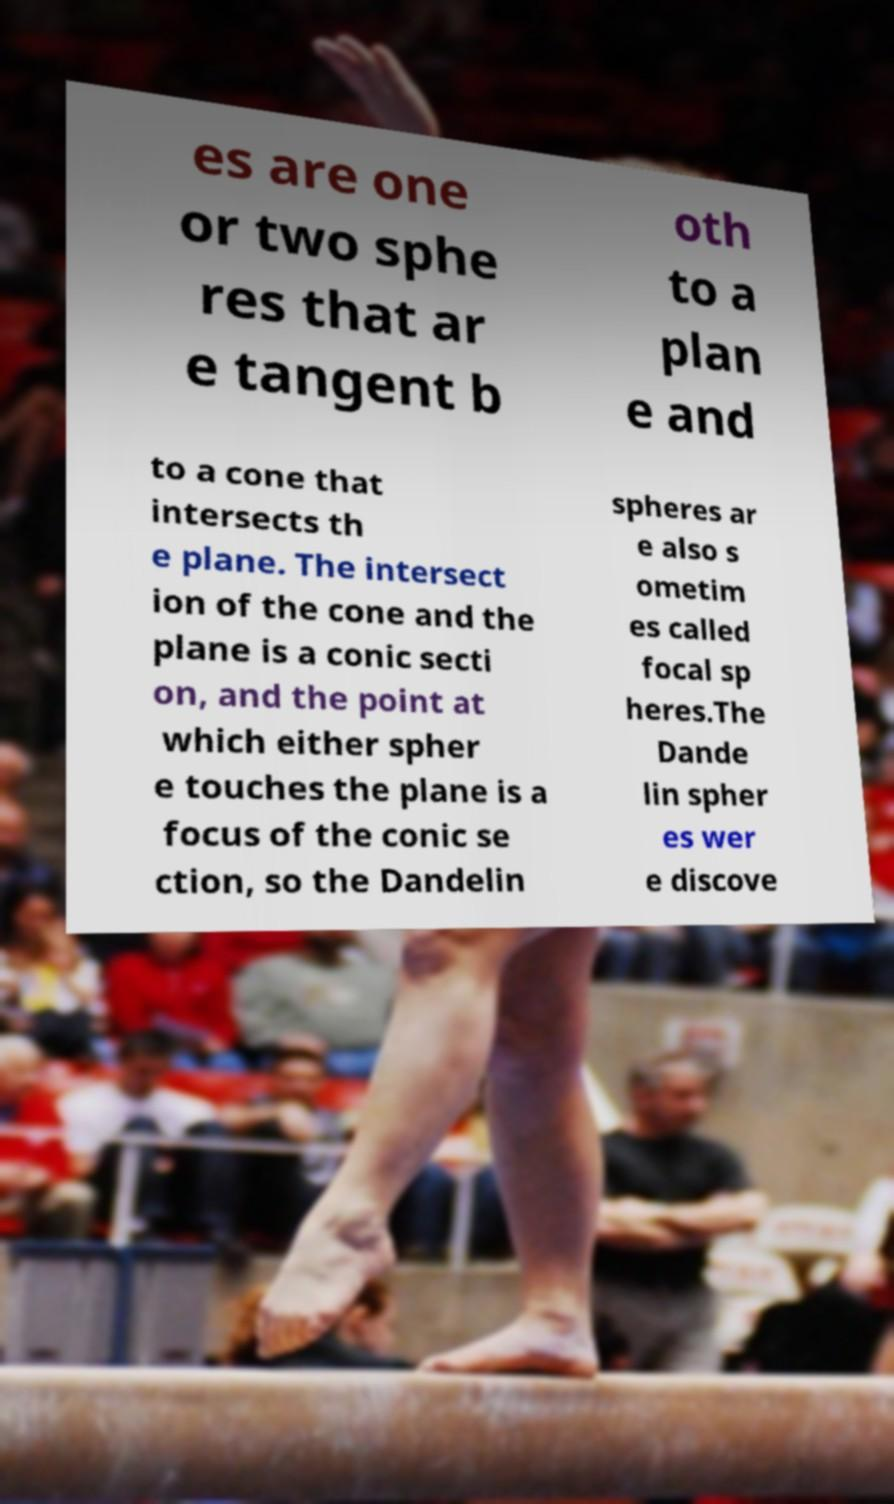There's text embedded in this image that I need extracted. Can you transcribe it verbatim? es are one or two sphe res that ar e tangent b oth to a plan e and to a cone that intersects th e plane. The intersect ion of the cone and the plane is a conic secti on, and the point at which either spher e touches the plane is a focus of the conic se ction, so the Dandelin spheres ar e also s ometim es called focal sp heres.The Dande lin spher es wer e discove 